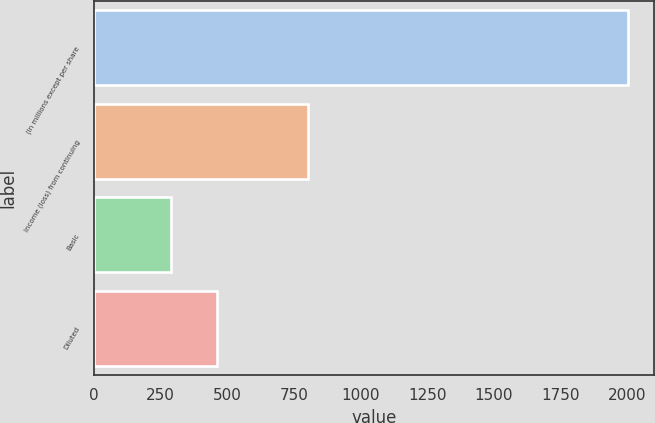Convert chart to OTSL. <chart><loc_0><loc_0><loc_500><loc_500><bar_chart><fcel>(In millions except per share<fcel>Income (loss) from continuing<fcel>Basic<fcel>Diluted<nl><fcel>2003<fcel>803.41<fcel>289.3<fcel>460.67<nl></chart> 